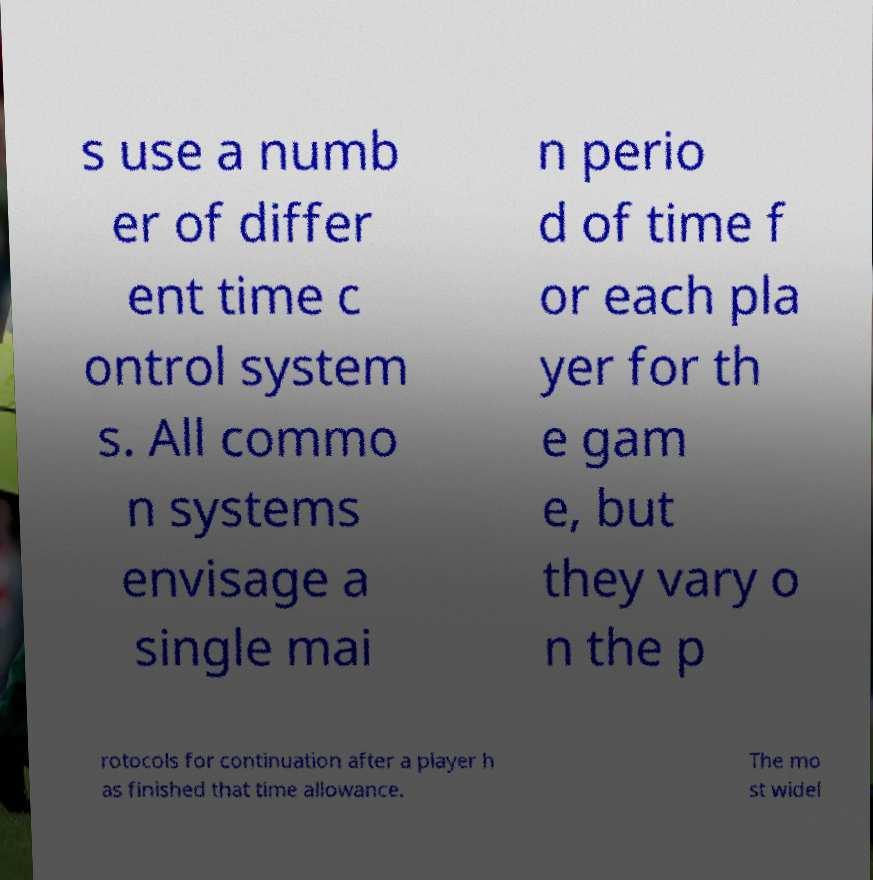Could you extract and type out the text from this image? s use a numb er of differ ent time c ontrol system s. All commo n systems envisage a single mai n perio d of time f or each pla yer for th e gam e, but they vary o n the p rotocols for continuation after a player h as finished that time allowance. The mo st widel 